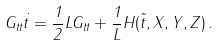<formula> <loc_0><loc_0><loc_500><loc_500>G _ { t t } { \dot { t } } = \frac { 1 } { 2 } L G _ { t t } + \frac { 1 } { L } H ( \tilde { t } , X , Y , Z ) \, .</formula> 